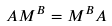<formula> <loc_0><loc_0><loc_500><loc_500>A M ^ { B } = M ^ { B } A</formula> 